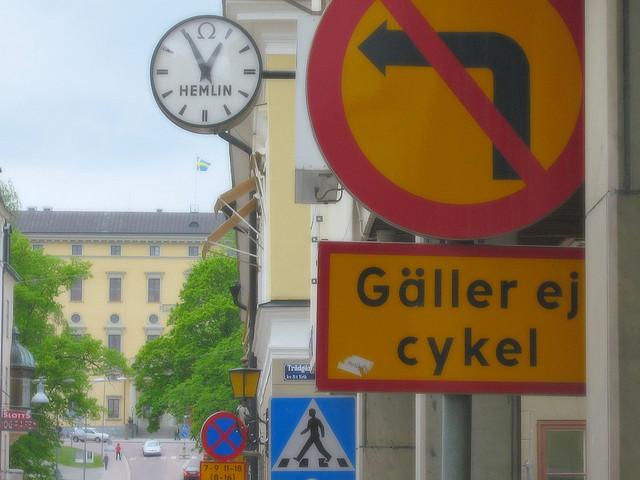<image>How far must the driver go before being allowed to turn? I don't know how far the driver must go before being allowed to turn. It could be several hundred yards, 1 block, to next corner, 3 blocks, 1 mile, or 2 blocks. How far must the driver go before being allowed to turn? I don't know how far the driver must go before being allowed to turn. It can be several hundred yards, 1 block, to the next corner, 3 blocks, 1 mile, or 2 blocks. 